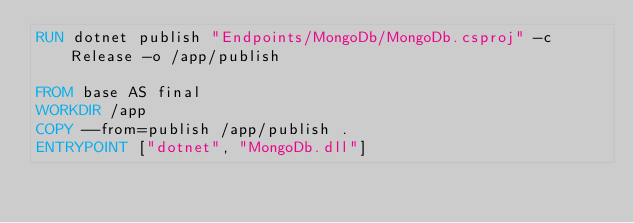<code> <loc_0><loc_0><loc_500><loc_500><_Dockerfile_>RUN dotnet publish "Endpoints/MongoDb/MongoDb.csproj" -c Release -o /app/publish

FROM base AS final
WORKDIR /app
COPY --from=publish /app/publish .
ENTRYPOINT ["dotnet", "MongoDb.dll"]
</code> 